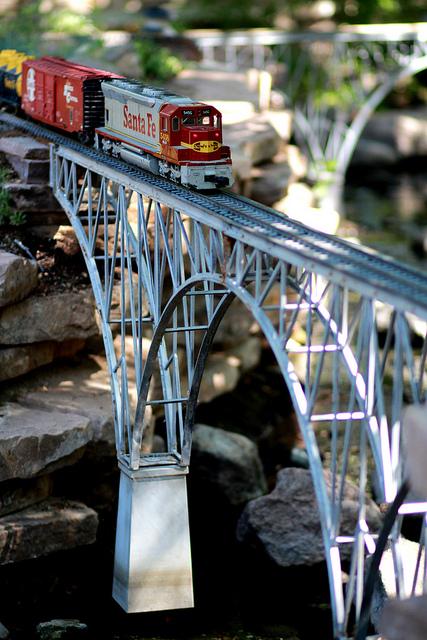Are these real or toys?
Write a very short answer. Toys. How many cars on the train?
Concise answer only. 3. Is this a hobby?
Give a very brief answer. Yes. 